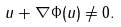Convert formula to latex. <formula><loc_0><loc_0><loc_500><loc_500>u + \nabla \Phi ( u ) \neq 0 .</formula> 